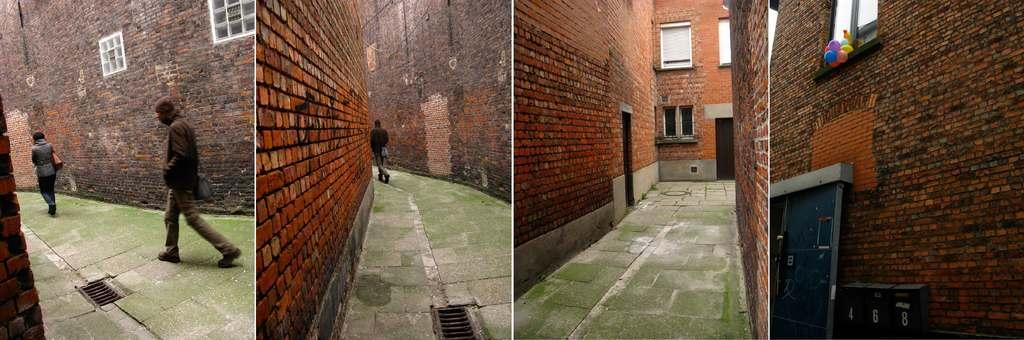What type of image is being described? The image is a collage. What can be seen on the wall in the image? There is a wall with objects in the image. Are there any people in the image? Yes, there are people in the image. What additional decorations are present in the image? Balloons are present in the image. What is visible beneath the wall and objects in the image? The ground is visible in the image. What type of furniture is being used by the donkey in the image? There is no donkey present in the image, so it is not possible to determine what type of furniture the donkey might be using. 